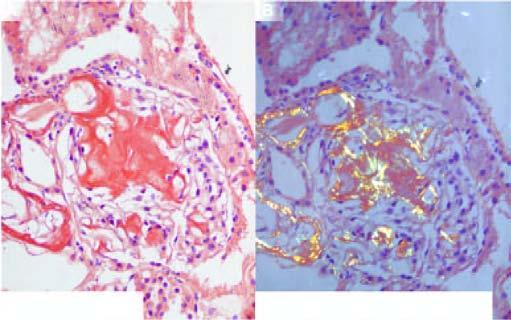what stained red-pink congophilia?
Answer the question using a single word or phrase. The amyloid deposits 